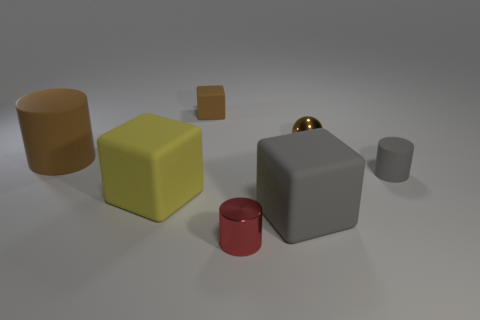There is a metal cylinder; does it have the same color as the rubber thing left of the yellow rubber thing?
Your response must be concise. No. Does the tiny rubber cube have the same color as the small metallic cylinder?
Your answer should be compact. No. Is the number of small brown metallic objects less than the number of brown objects?
Your answer should be compact. Yes. What number of other objects are the same color as the metal ball?
Ensure brevity in your answer.  2. What number of big blocks are there?
Your response must be concise. 2. Is the number of objects on the right side of the brown ball less than the number of things?
Your answer should be very brief. Yes. Do the small brown thing to the right of the shiny cylinder and the red cylinder have the same material?
Make the answer very short. Yes. The shiny thing in front of the gray rubber object to the right of the big object that is in front of the yellow cube is what shape?
Make the answer very short. Cylinder. Are there any yellow spheres of the same size as the gray rubber cylinder?
Keep it short and to the point. No. What size is the brown cylinder?
Your answer should be compact. Large. 